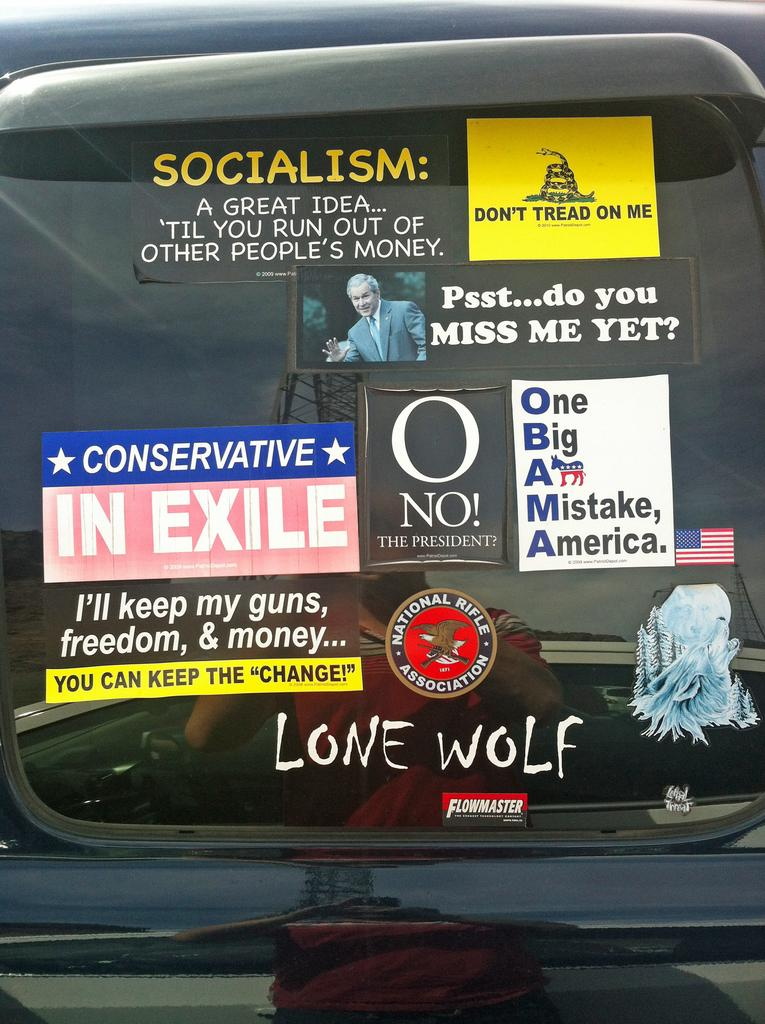What object is present in the image that is typically used for drinking? There is a glass in the image. What is covering the glass in the image? There are posters pasted on the glass. What type of belief is depicted on the glass in the image? There is no belief depicted on the glass in the image; it only shows posters. 